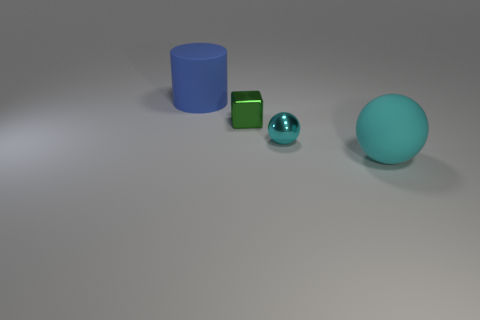Add 1 small green things. How many objects exist? 5 Subtract all cylinders. How many objects are left? 3 Add 1 cyan rubber balls. How many cyan rubber balls exist? 2 Subtract 0 brown spheres. How many objects are left? 4 Subtract all yellow blocks. Subtract all yellow spheres. How many blocks are left? 1 Subtract all cylinders. Subtract all small blocks. How many objects are left? 2 Add 3 tiny shiny blocks. How many tiny shiny blocks are left? 4 